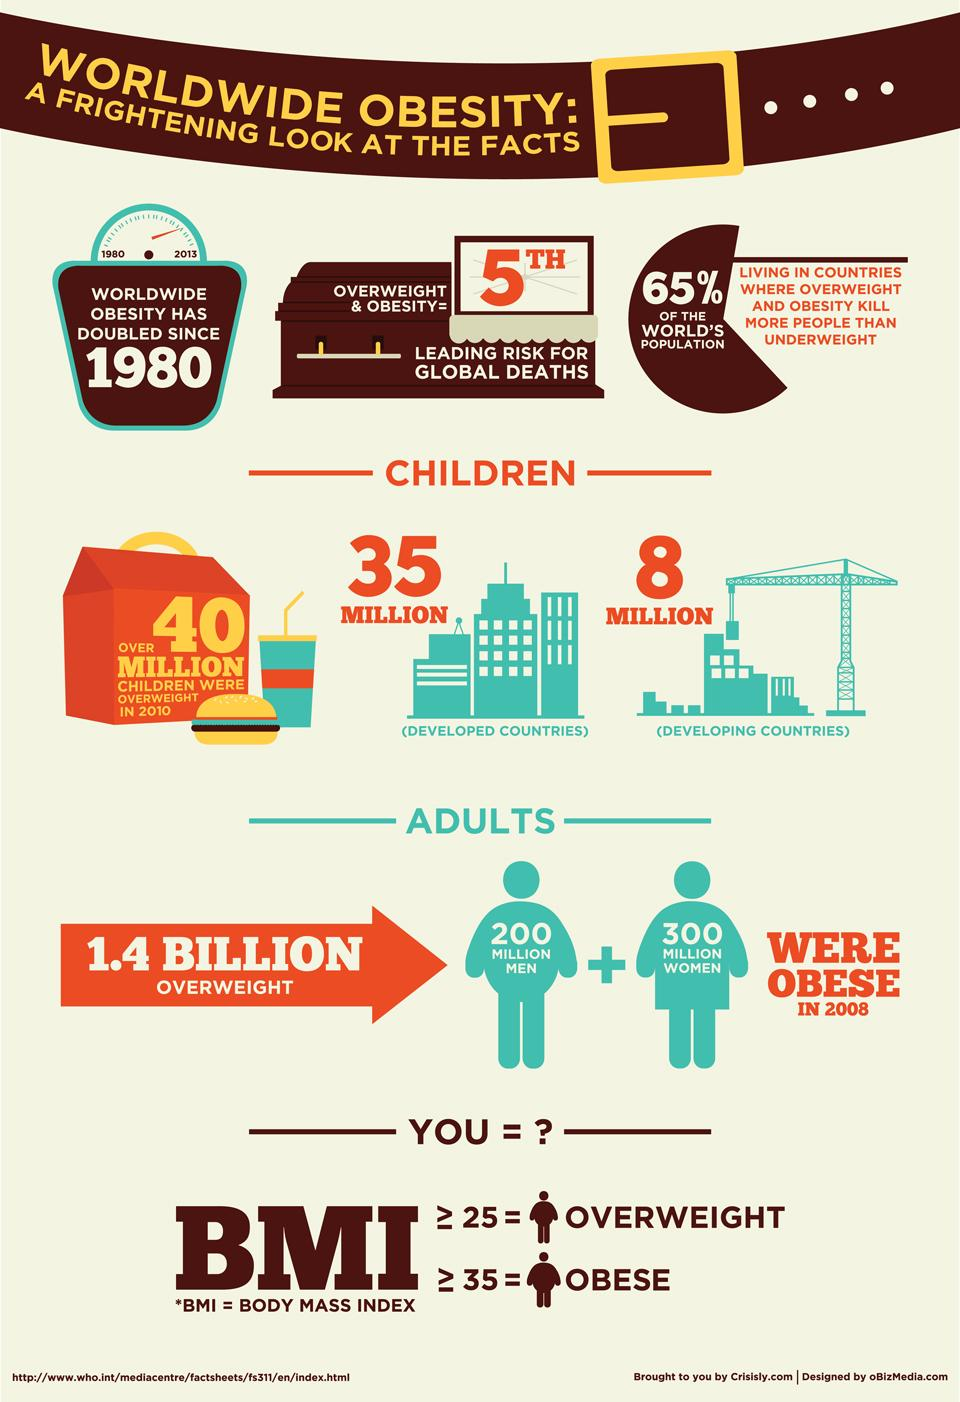Outline some significant characteristics in this image. Individuals who are not overweight are those with a Body Mass Index (BMI) less than 25 or a BMI greater than 25. In 2010, an estimated 43 million children in both developed and developing countries were overweight. In 2008, women were more likely to be obese than men. 